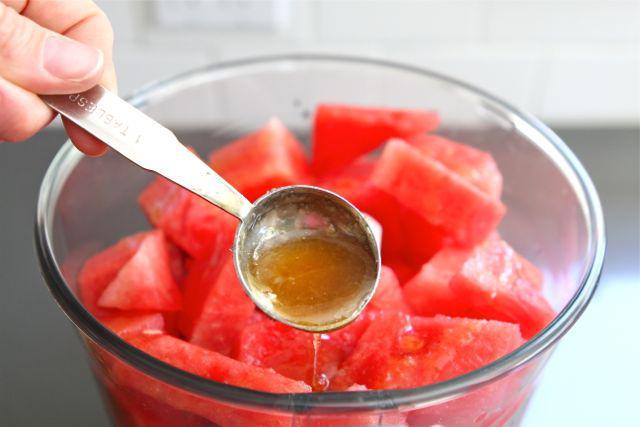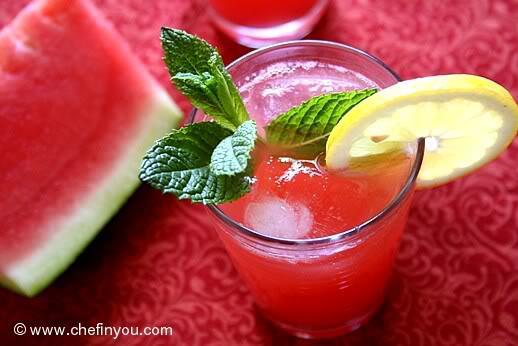The first image is the image on the left, the second image is the image on the right. For the images displayed, is the sentence "Left and right images show the same number of prepared drinks in serving cups." factually correct? Answer yes or no. No. The first image is the image on the left, the second image is the image on the right. For the images displayed, is the sentence "There is more than one slice of lemon in the image on the left" factually correct? Answer yes or no. No. 